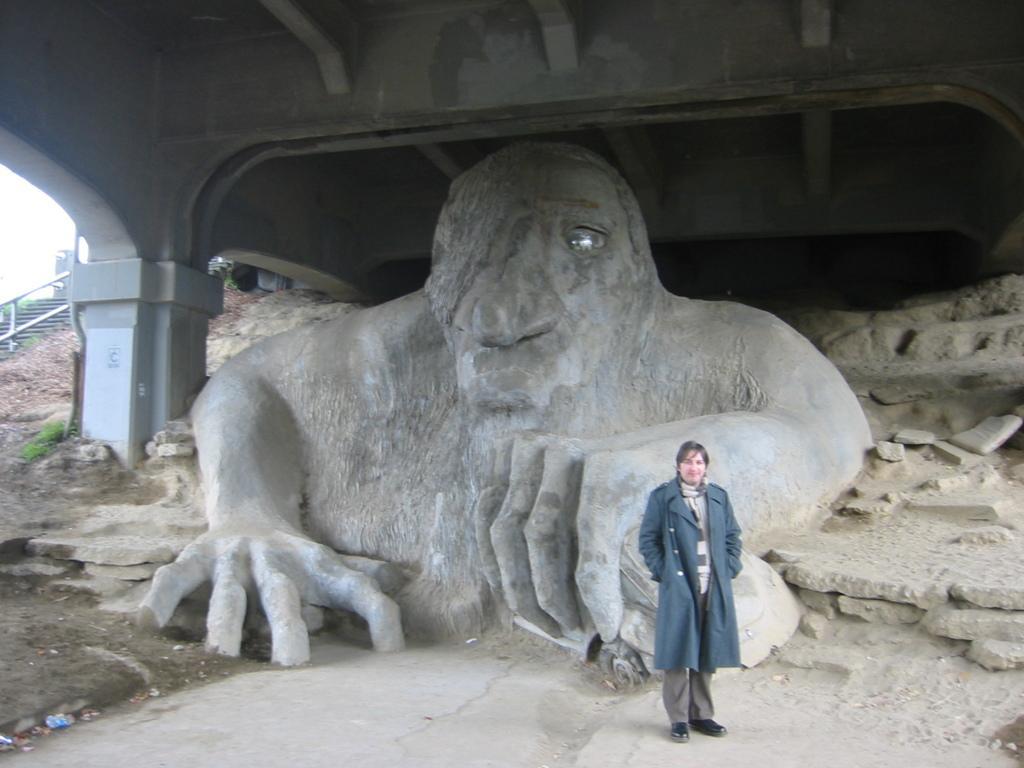How would you summarize this image in a sentence or two? In the foreground of the picture there is a person standing. In the center there is a sculpture. In the background, to the left there is staircase. At the top it is bridge. 